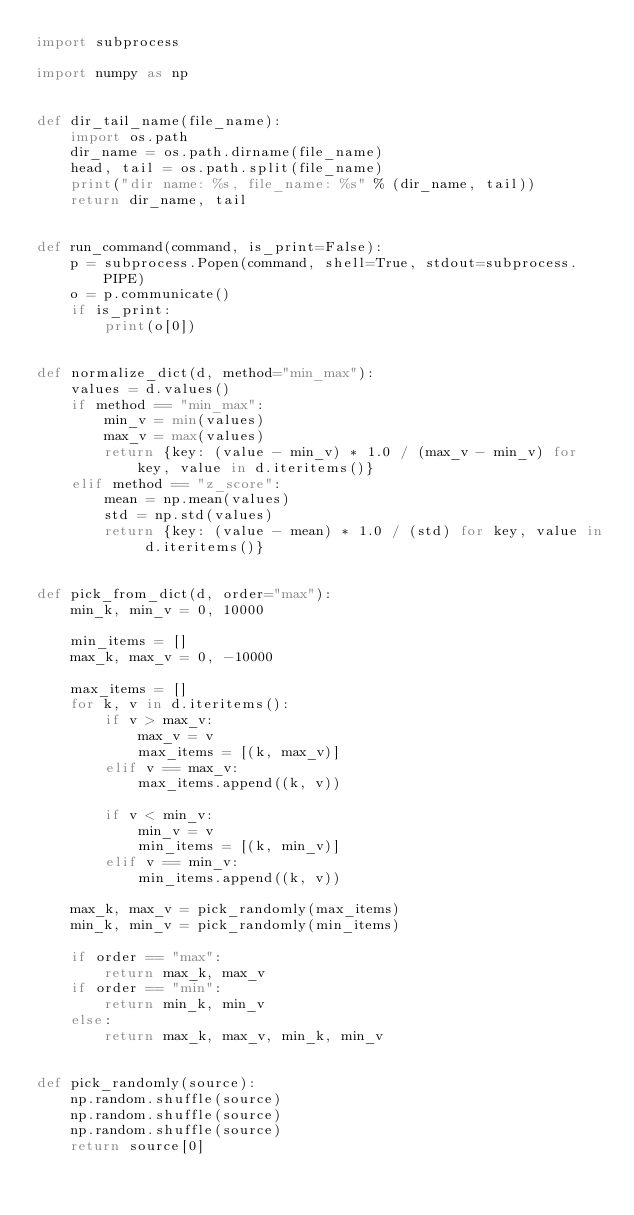Convert code to text. <code><loc_0><loc_0><loc_500><loc_500><_Python_>import subprocess

import numpy as np


def dir_tail_name(file_name):
    import os.path
    dir_name = os.path.dirname(file_name)
    head, tail = os.path.split(file_name)
    print("dir name: %s, file_name: %s" % (dir_name, tail))
    return dir_name, tail


def run_command(command, is_print=False):
    p = subprocess.Popen(command, shell=True, stdout=subprocess.PIPE)
    o = p.communicate()
    if is_print:
        print(o[0])


def normalize_dict(d, method="min_max"):
    values = d.values()
    if method == "min_max":
        min_v = min(values)
        max_v = max(values)
        return {key: (value - min_v) * 1.0 / (max_v - min_v) for key, value in d.iteritems()}
    elif method == "z_score":
        mean = np.mean(values)
        std = np.std(values)
        return {key: (value - mean) * 1.0 / (std) for key, value in d.iteritems()}


def pick_from_dict(d, order="max"):
    min_k, min_v = 0, 10000

    min_items = []
    max_k, max_v = 0, -10000

    max_items = []
    for k, v in d.iteritems():
        if v > max_v:
            max_v = v
            max_items = [(k, max_v)]
        elif v == max_v:
            max_items.append((k, v))

        if v < min_v:
            min_v = v
            min_items = [(k, min_v)]
        elif v == min_v:
            min_items.append((k, v))

    max_k, max_v = pick_randomly(max_items)
    min_k, min_v = pick_randomly(min_items)

    if order == "max":
        return max_k, max_v
    if order == "min":
        return min_k, min_v
    else:
        return max_k, max_v, min_k, min_v


def pick_randomly(source):
    np.random.shuffle(source)
    np.random.shuffle(source)
    np.random.shuffle(source)
    return source[0]
</code> 